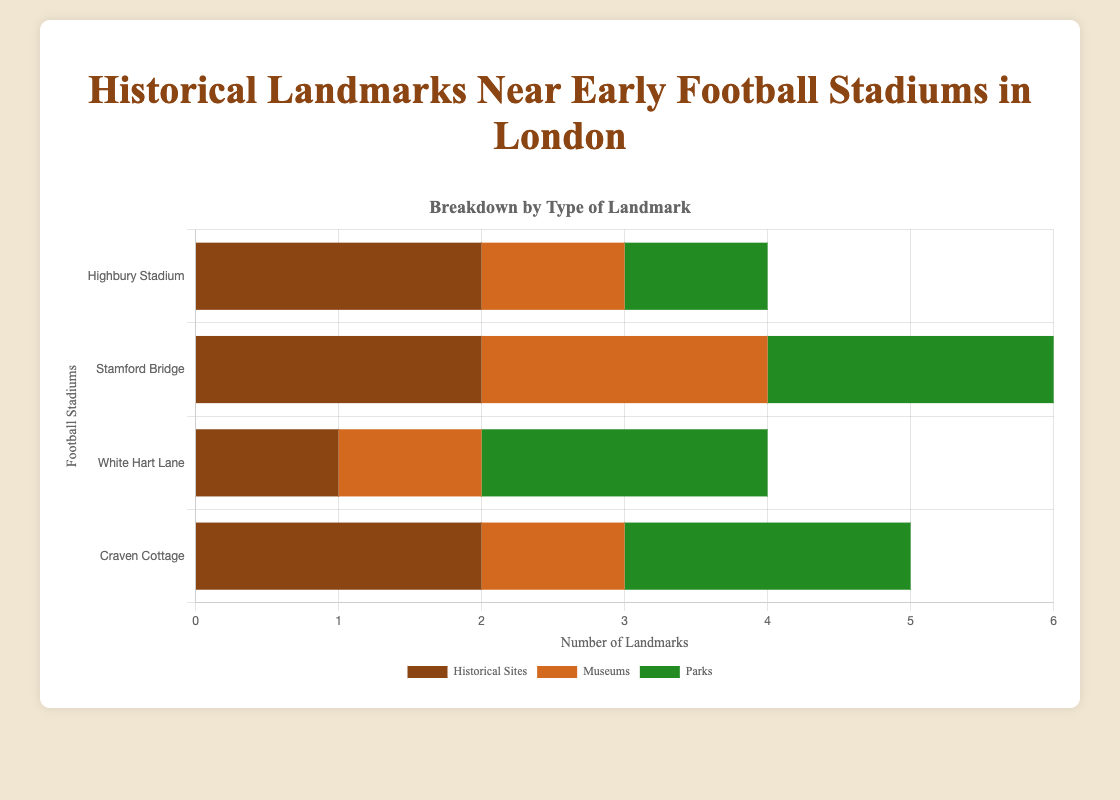Which stadium has the highest total number of landmarks? Summing the number of landmarks across all categories for each stadium: Highbury Stadium (2+1+1=4), Stamford Bridge (2+2+2=6), White Hart Lane (1+1+2=4), and Craven Cottage (2+1+2=5). Stamford Bridge has the highest total number (6).
Answer: Stamford Bridge Which stadium has the least number of museums? Comparing the number of museums at each stadium: Highbury Stadium (1), Stamford Bridge (2), White Hart Lane (1), and Craven Cottage (1). Highbury Stadium, White Hart Lane, and Craven Cottage all have the least number (1 museum each).
Answer: Highbury Stadium, White Hart Lane, and Craven Cottage How many more parks does Stamford Bridge have compared to Highbury Stadium? Highbury Stadium has 1 park while Stamford Bridge has 2 parks. The difference is 2 - 1 = 1 park.
Answer: 1 park What is the total number of historical sites across all stadiums? Summing the number of historical sites for each stadium: Highbury Stadium (2), Stamford Bridge (2), White Hart Lane (1), Craven Cottage (2). The total is 2+2+1+2 = 7 historical sites.
Answer: 7 Which stadiums have an equal number of parks? Comparing the parks at each stadium: Highbury Stadium (1), Stamford Bridge (2), White Hart Lane (2), Craven Cottage (2). Stamford Bridge, White Hart Lane, and Craven Cottage each have 2 parks.
Answer: Stamford Bridge, White Hart Lane, and Craven Cottage Does White Hart Lane have more museums or historical sites? White Hart Lane has 1 museum and 1 historical site. Both are equal in number.
Answer: Both are equal Which type of landmark has the highest count near Stamford Bridge? Stamford Bridge has 2 historical sites, 2 museums, and 2 parks. All three types have the same highest count (2).
Answer: All types are equal How many parks are there in total near Craven Cottage and White Hart Lane combined? The number of parks near Craven Cottage is 2 and near White Hart Lane is 2. The combined total is 2+2 = 4 parks.
Answer: 4 parks 